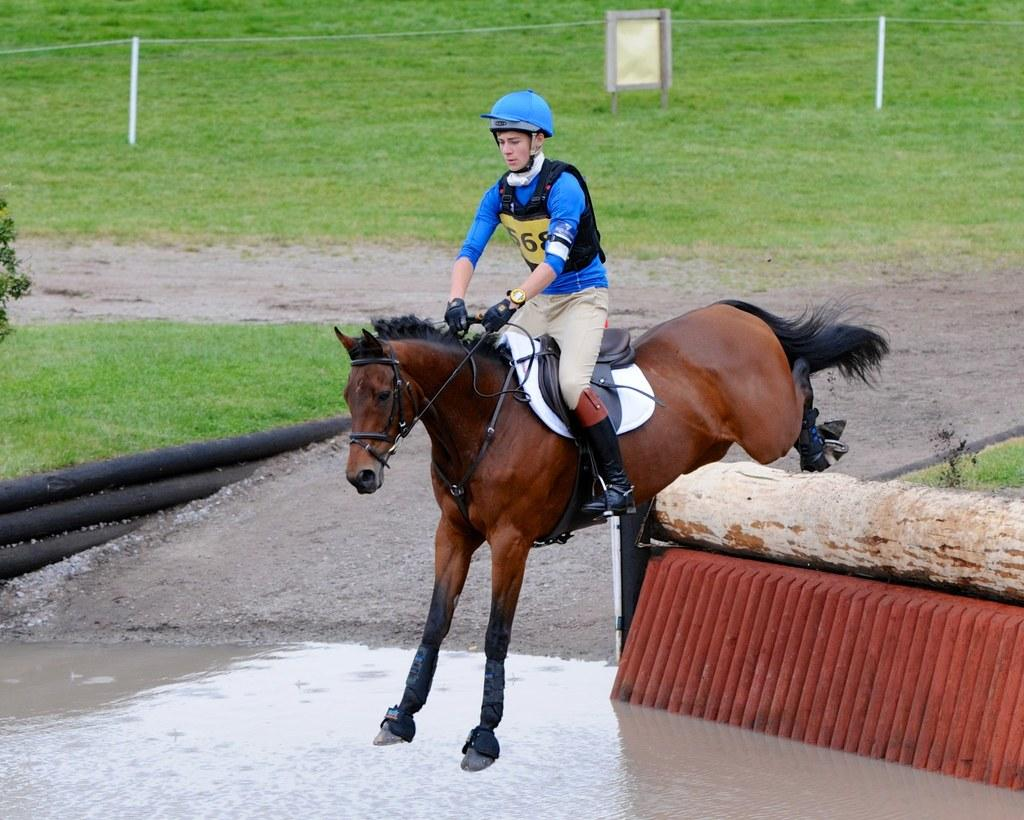What is the main subject of the image? There is a man in the image. What is the man doing in the image? The man is seated on a horse. What is the man wearing in the image? The man is wearing a helmet. What can be seen at the bottom of the image? There is water visible at the bottom of the image. What type of vegetation is in the background of the image? There is grass in the background of the image. What structures can be seen in the background of the image? There are pipes in the background of the image. What type of flower is the man holding in the image? There is no flower present in the image; the man is seated on a horse and wearing a helmet. 